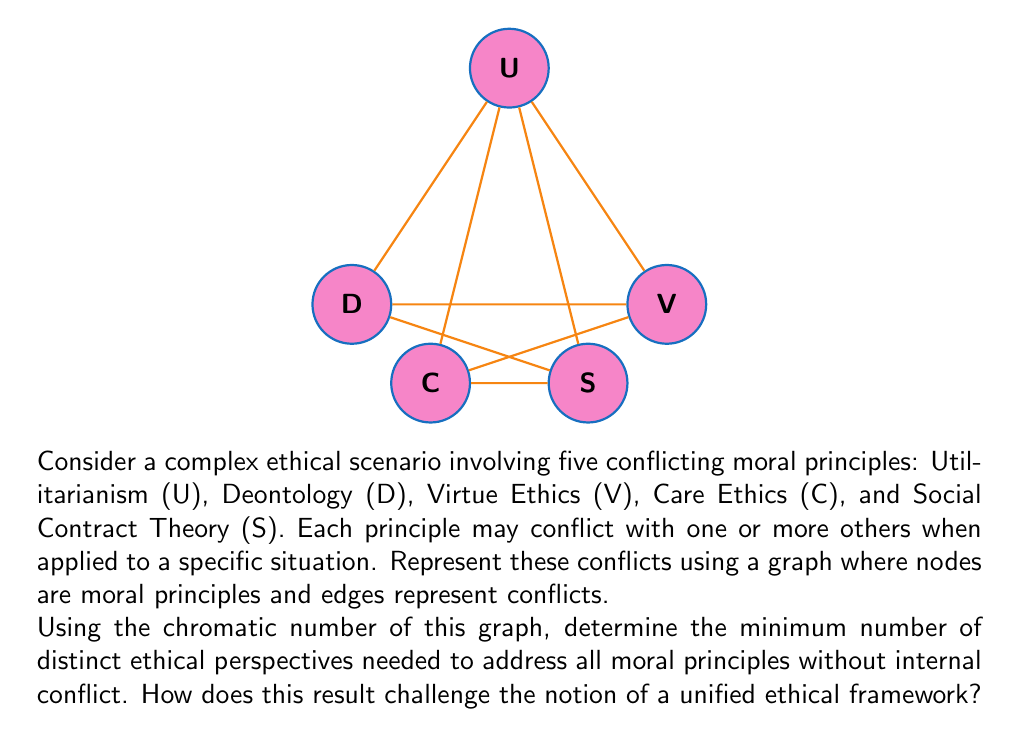Show me your answer to this math problem. To solve this problem, we need to follow these steps:

1) First, we need to understand what the graph represents:
   - Each node represents a moral principle
   - Each edge represents a conflict between two principles

2) The chromatic number of a graph is the minimum number of colors needed to color the vertices so that no two adjacent vertices share the same color. In this context, it represents the minimum number of distinct ethical perspectives needed to address all moral principles without internal conflict.

3) To find the chromatic number, we can use a greedy coloring algorithm:
   - Start with U: Color 1
   - D is adjacent to U: Color 2
   - V is adjacent to U and D: Color 3
   - C is adjacent to U and D: Color 3
   - S is adjacent to U, D, and C: Color 4

4) Therefore, the chromatic number of this graph is 4.

5) Interpreting the result:
   - We need at least 4 distinct ethical perspectives to address these 5 moral principles without internal conflict.
   - This challenges the notion of a unified ethical framework because it shows that these common moral principles cannot be consistently applied simultaneously without contradiction.
   - It suggests that ethical decision-making in complex scenarios may require a pluralistic approach, considering multiple ethical perspectives rather than relying on a single, unified framework.

6) From an ethics philosopher's perspective, this result:
   - Highlights the complexity and potential incompatibility of different moral theories
   - Encourages a more nuanced and context-dependent approach to ethical reasoning
   - Suggests that ethical decision-making might benefit from considering multiple perspectives rather than adhering strictly to a single moral theory
Answer: Chromatic number: 4. This challenges unified ethical frameworks by demonstrating inherent conflicts between moral principles, necessitating a pluralistic approach. 